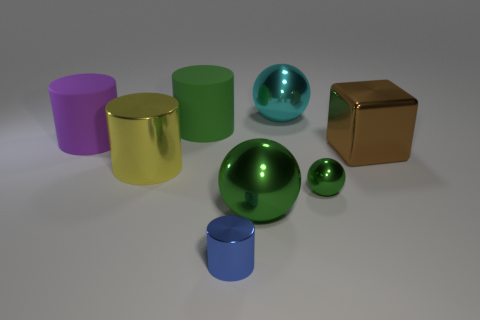There is a cylinder that is the same color as the tiny sphere; what is it made of?
Your answer should be compact. Rubber. How many objects are either red cylinders or cyan things?
Ensure brevity in your answer.  1. Is there another big metallic thing of the same shape as the large brown object?
Your answer should be very brief. No. Are there fewer blue cylinders than big red rubber cylinders?
Keep it short and to the point. No. Is the big cyan metal thing the same shape as the purple object?
Keep it short and to the point. No. How many objects are either purple things or metal objects right of the blue object?
Make the answer very short. 5. What number of tiny gray cubes are there?
Ensure brevity in your answer.  0. Are there any cyan cylinders that have the same size as the cyan shiny object?
Your response must be concise. No. Are there fewer large yellow cylinders that are behind the large cyan sphere than blue shiny cylinders?
Make the answer very short. Yes. Do the purple rubber thing and the blue shiny object have the same size?
Offer a terse response. No. 